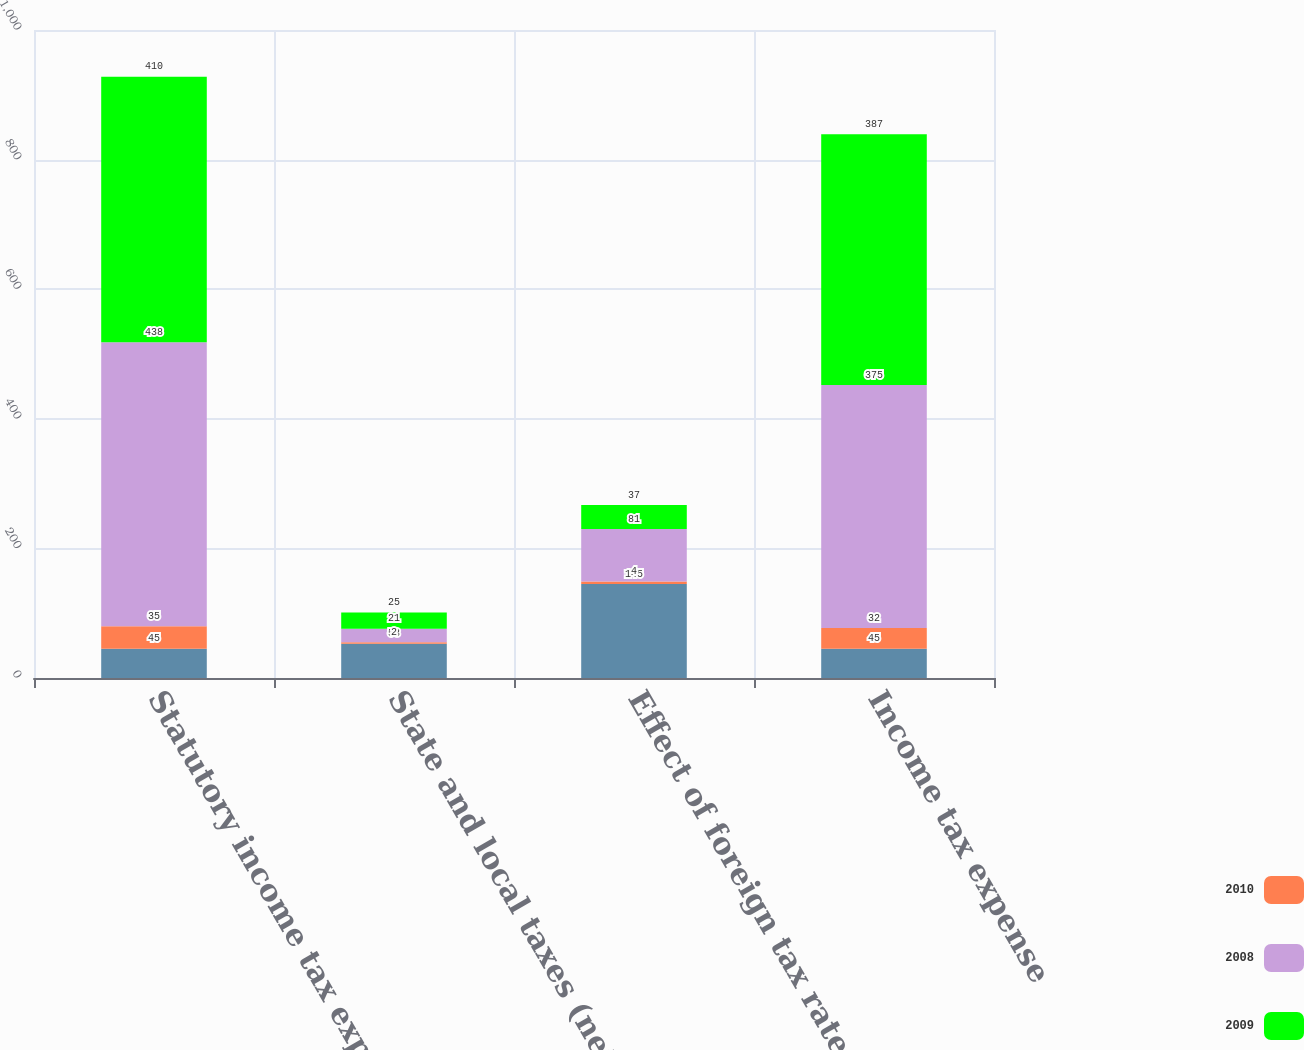Convert chart. <chart><loc_0><loc_0><loc_500><loc_500><stacked_bar_chart><ecel><fcel>Statutory income tax expense<fcel>State and local taxes (net of<fcel>Effect of foreign tax rates<fcel>Income tax expense<nl><fcel>nan<fcel>45<fcel>53<fcel>145<fcel>45<nl><fcel>2010<fcel>35<fcel>2<fcel>4<fcel>32<nl><fcel>2008<fcel>438<fcel>21<fcel>81<fcel>375<nl><fcel>2009<fcel>410<fcel>25<fcel>37<fcel>387<nl></chart> 